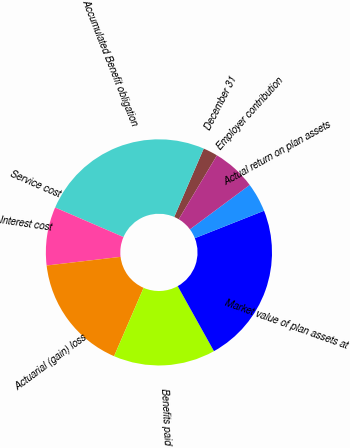Convert chart to OTSL. <chart><loc_0><loc_0><loc_500><loc_500><pie_chart><fcel>December 31<fcel>Accumulated Benefit obligation<fcel>Service cost<fcel>Interest cost<fcel>Actuarial (gain) loss<fcel>Benefits paid<fcel>Market value of plan assets at<fcel>Actual return on plan assets<fcel>Employer contribution<nl><fcel>2.09%<fcel>24.99%<fcel>0.01%<fcel>8.34%<fcel>16.66%<fcel>14.58%<fcel>22.91%<fcel>4.17%<fcel>6.25%<nl></chart> 